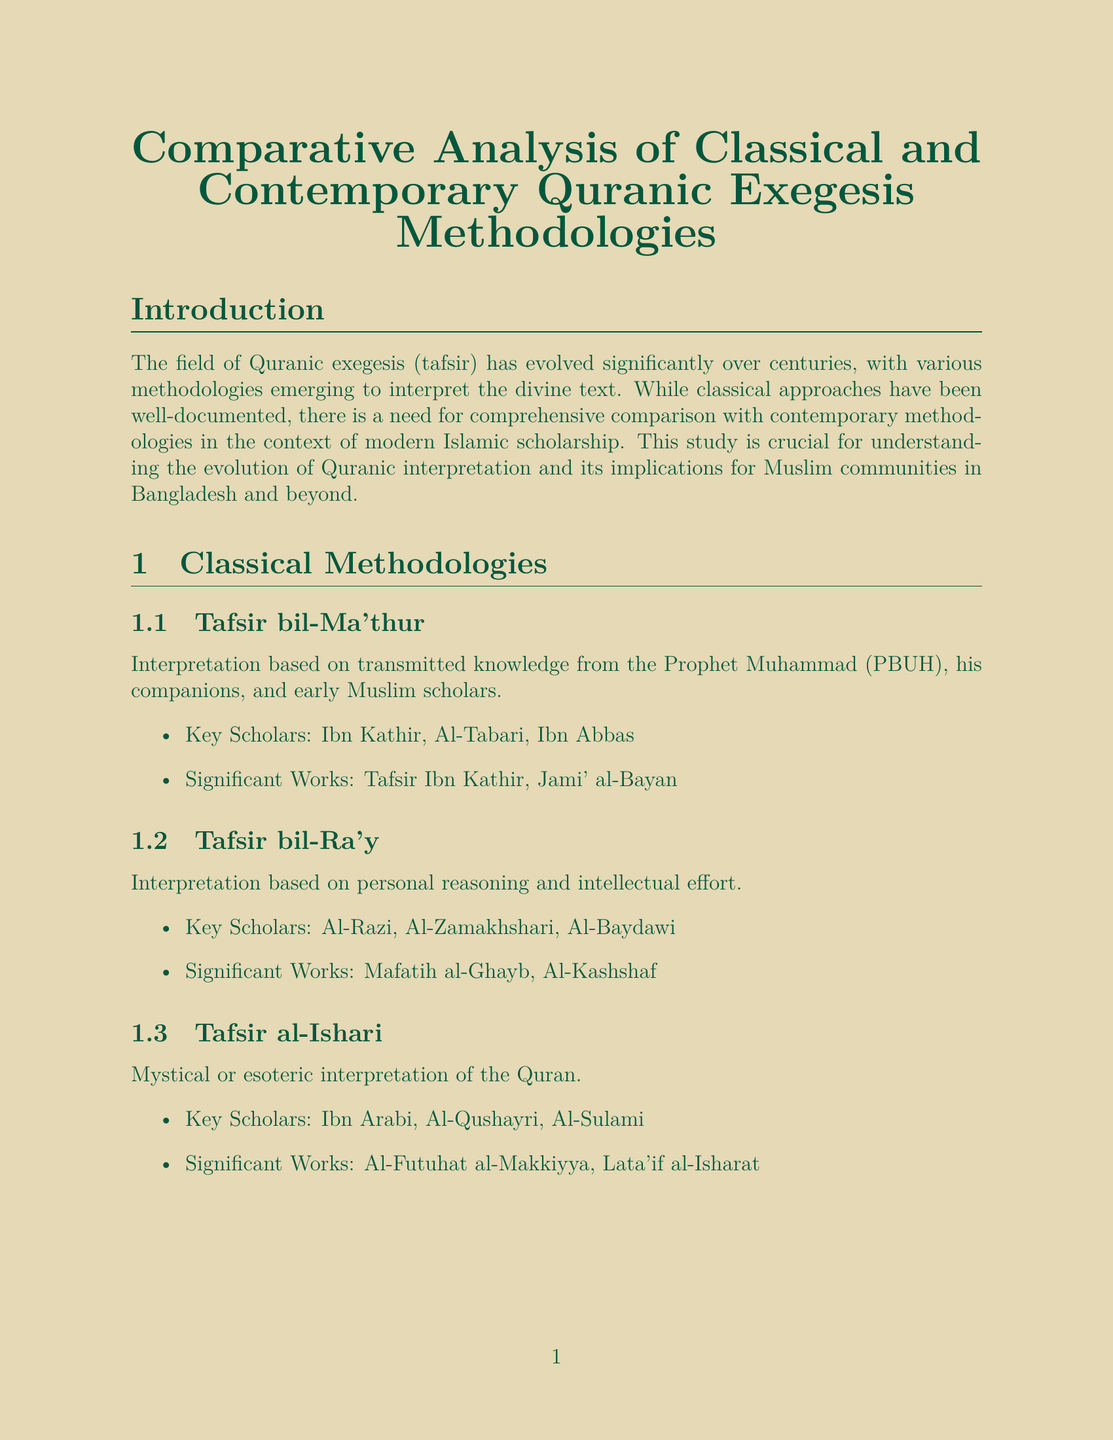What is the title of the report? The title of the report is "Comparative Analysis of Classical and Contemporary Quranic Exegesis Methodologies."
Answer: Comparative Analysis of Classical and Contemporary Quranic Exegesis Methodologies Who are three key scholars of Tafsir bil-Ma'thur? The key scholars of Tafsir bil-Ma'thur mentioned in the document are Ibn Kathir, Al-Tabari, and Ibn Abbas.
Answer: Ibn Kathir, Al-Tabari, Ibn Abbas What methodology emphasizes modern knowledge integration? The methodology that emphasizes modern knowledge integration is Scientific Exegesis.
Answer: Scientific Exegesis What approach addresses contemporary issues not mentioned in classical texts? The approach that addresses contemporary issues not explicitly mentioned in classical texts is Challenges and Criticisms.
Answer: Challenges and Criticisms How many academic institutions are listed in the Bangladeshi context? The document lists three academic institutions: Islamic University, Kushtia; University of Dhaka (Department of Islamic Studies); and International Islamic University Chittagong.
Answer: Three Who are three key scholars of the Socio-historical Approach? The key scholars of the Socio-historical Approach mentioned in the document are Nasr Abu Zayd, Amina Wadud, and Fazlur Rahman.
Answer: Nasr Abu Zayd, Amina Wadud, Fazlur Rahman What conclusion is drawn about classical and contemporary methodologies? The conclusion emphasizes that both methodologies offer valuable insights into Quranic interpretation.
Answer: Offer valuable insights into Quranic interpretation 